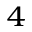<formula> <loc_0><loc_0><loc_500><loc_500>^ { 4 }</formula> 